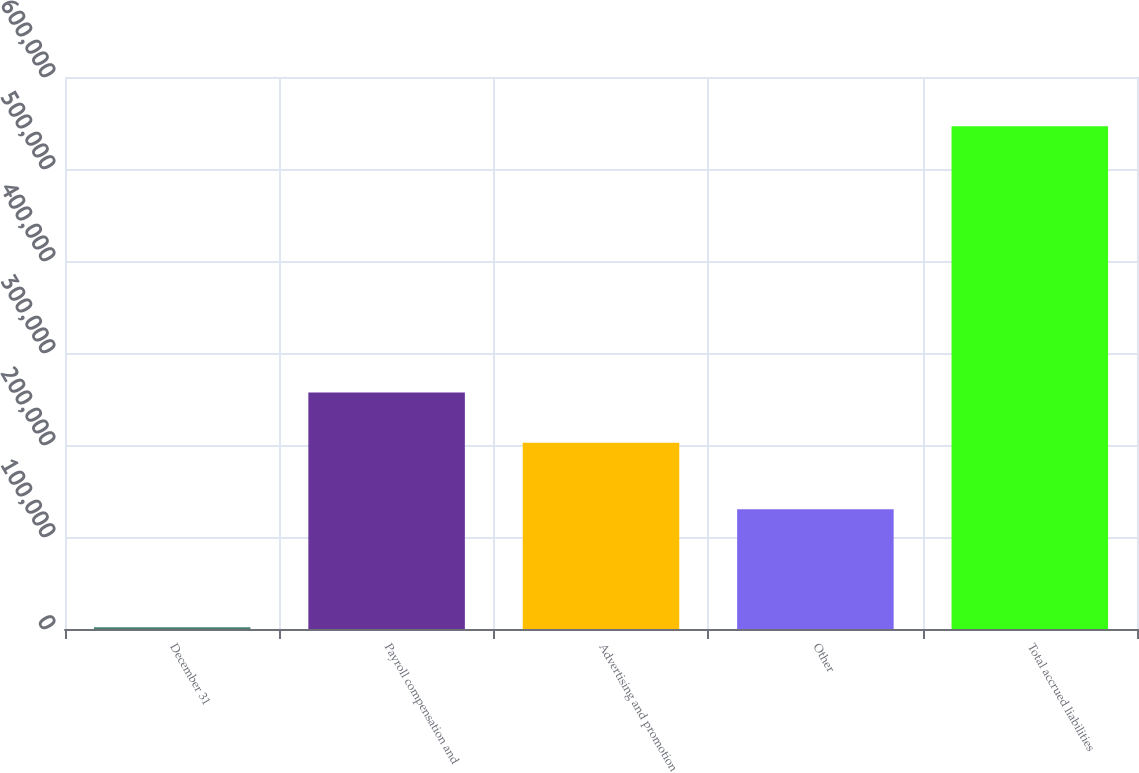Convert chart to OTSL. <chart><loc_0><loc_0><loc_500><loc_500><bar_chart><fcel>December 31<fcel>Payroll compensation and<fcel>Advertising and promotion<fcel>Other<fcel>Total accrued liabilities<nl><fcel>2009<fcel>256992<fcel>202547<fcel>130200<fcel>546462<nl></chart> 